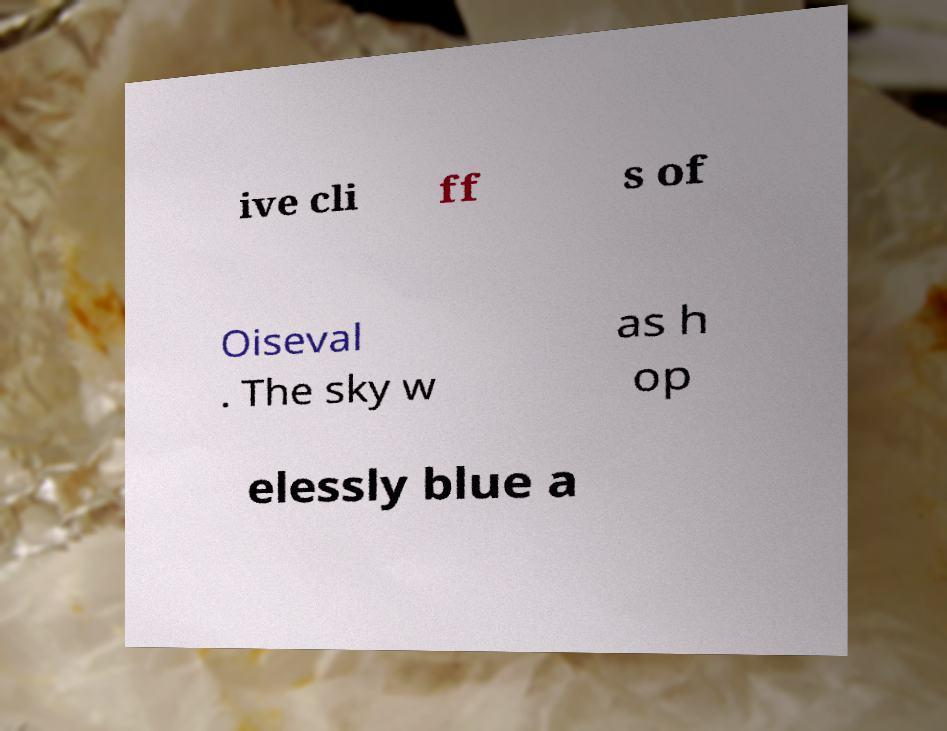There's text embedded in this image that I need extracted. Can you transcribe it verbatim? ive cli ff s of Oiseval . The sky w as h op elessly blue a 